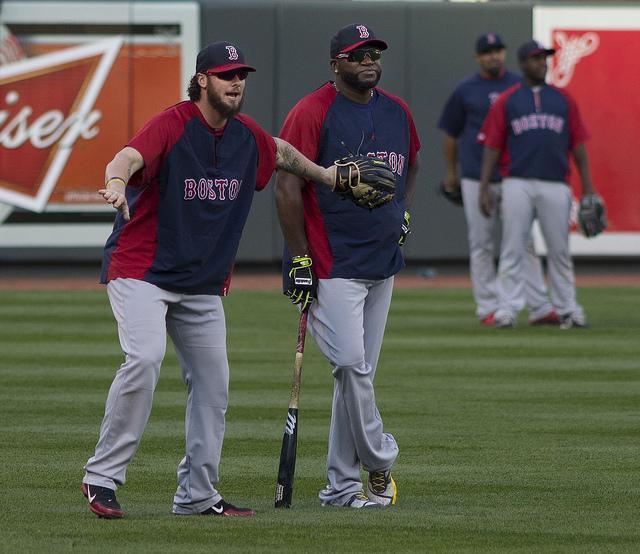What team do the men on the field play for?
Make your selection from the four choices given to correctly answer the question.
Options: Mets, yankees, rays, red sox. Red sox. 